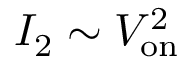<formula> <loc_0><loc_0><loc_500><loc_500>I _ { 2 } \sim V _ { o n } ^ { 2 }</formula> 